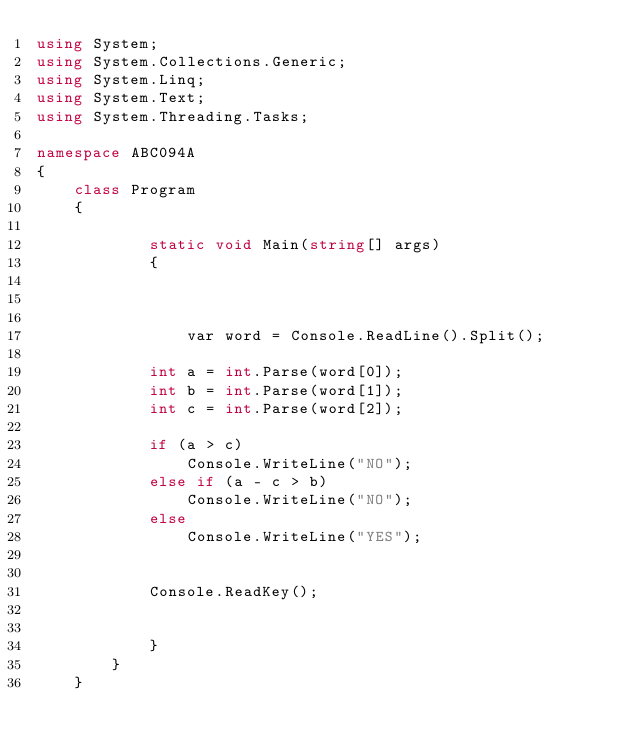Convert code to text. <code><loc_0><loc_0><loc_500><loc_500><_C#_>using System;
using System.Collections.Generic;
using System.Linq;
using System.Text;
using System.Threading.Tasks;

namespace ABC094A
{
    class Program
    {
        
            static void Main(string[] args)
            {



                var word = Console.ReadLine().Split();

            int a = int.Parse(word[0]);
            int b = int.Parse(word[1]);
            int c = int.Parse(word[2]);

            if (a > c)
                Console.WriteLine("NO");
            else if (a - c > b)
                Console.WriteLine("NO");
            else
                Console.WriteLine("YES");


            Console.ReadKey();


            }
        }
    }

</code> 